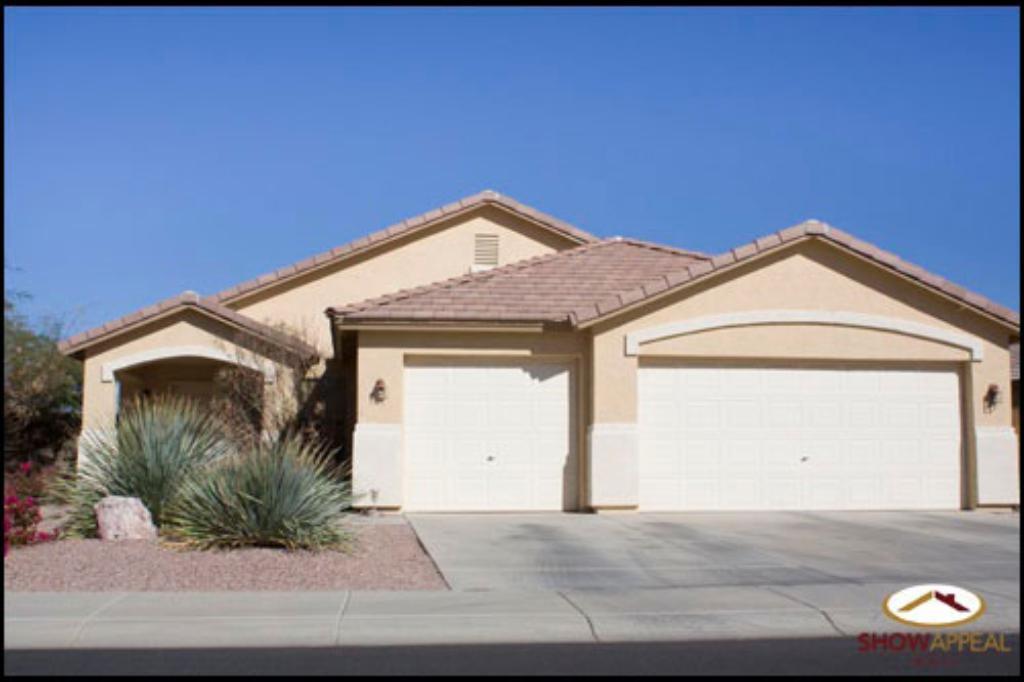Can you describe this image briefly? In this picture we can see the building. On the left we can see trees, plants, flowers and grass. At the top there is a sky. In the bottom right corner there is a watermark. 